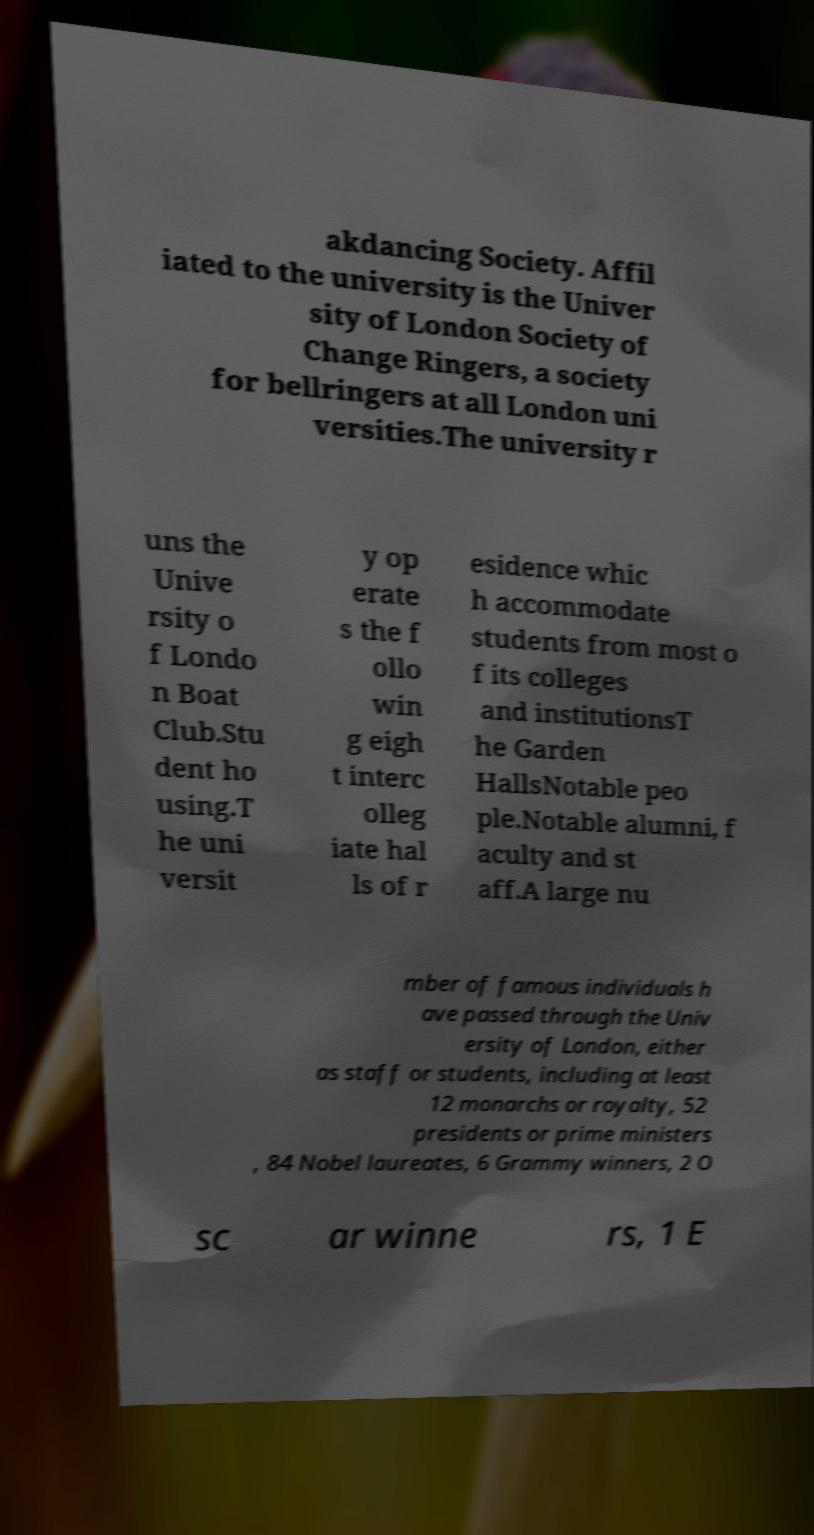I need the written content from this picture converted into text. Can you do that? akdancing Society. Affil iated to the university is the Univer sity of London Society of Change Ringers, a society for bellringers at all London uni versities.The university r uns the Unive rsity o f Londo n Boat Club.Stu dent ho using.T he uni versit y op erate s the f ollo win g eigh t interc olleg iate hal ls of r esidence whic h accommodate students from most o f its colleges and institutionsT he Garden HallsNotable peo ple.Notable alumni, f aculty and st aff.A large nu mber of famous individuals h ave passed through the Univ ersity of London, either as staff or students, including at least 12 monarchs or royalty, 52 presidents or prime ministers , 84 Nobel laureates, 6 Grammy winners, 2 O sc ar winne rs, 1 E 